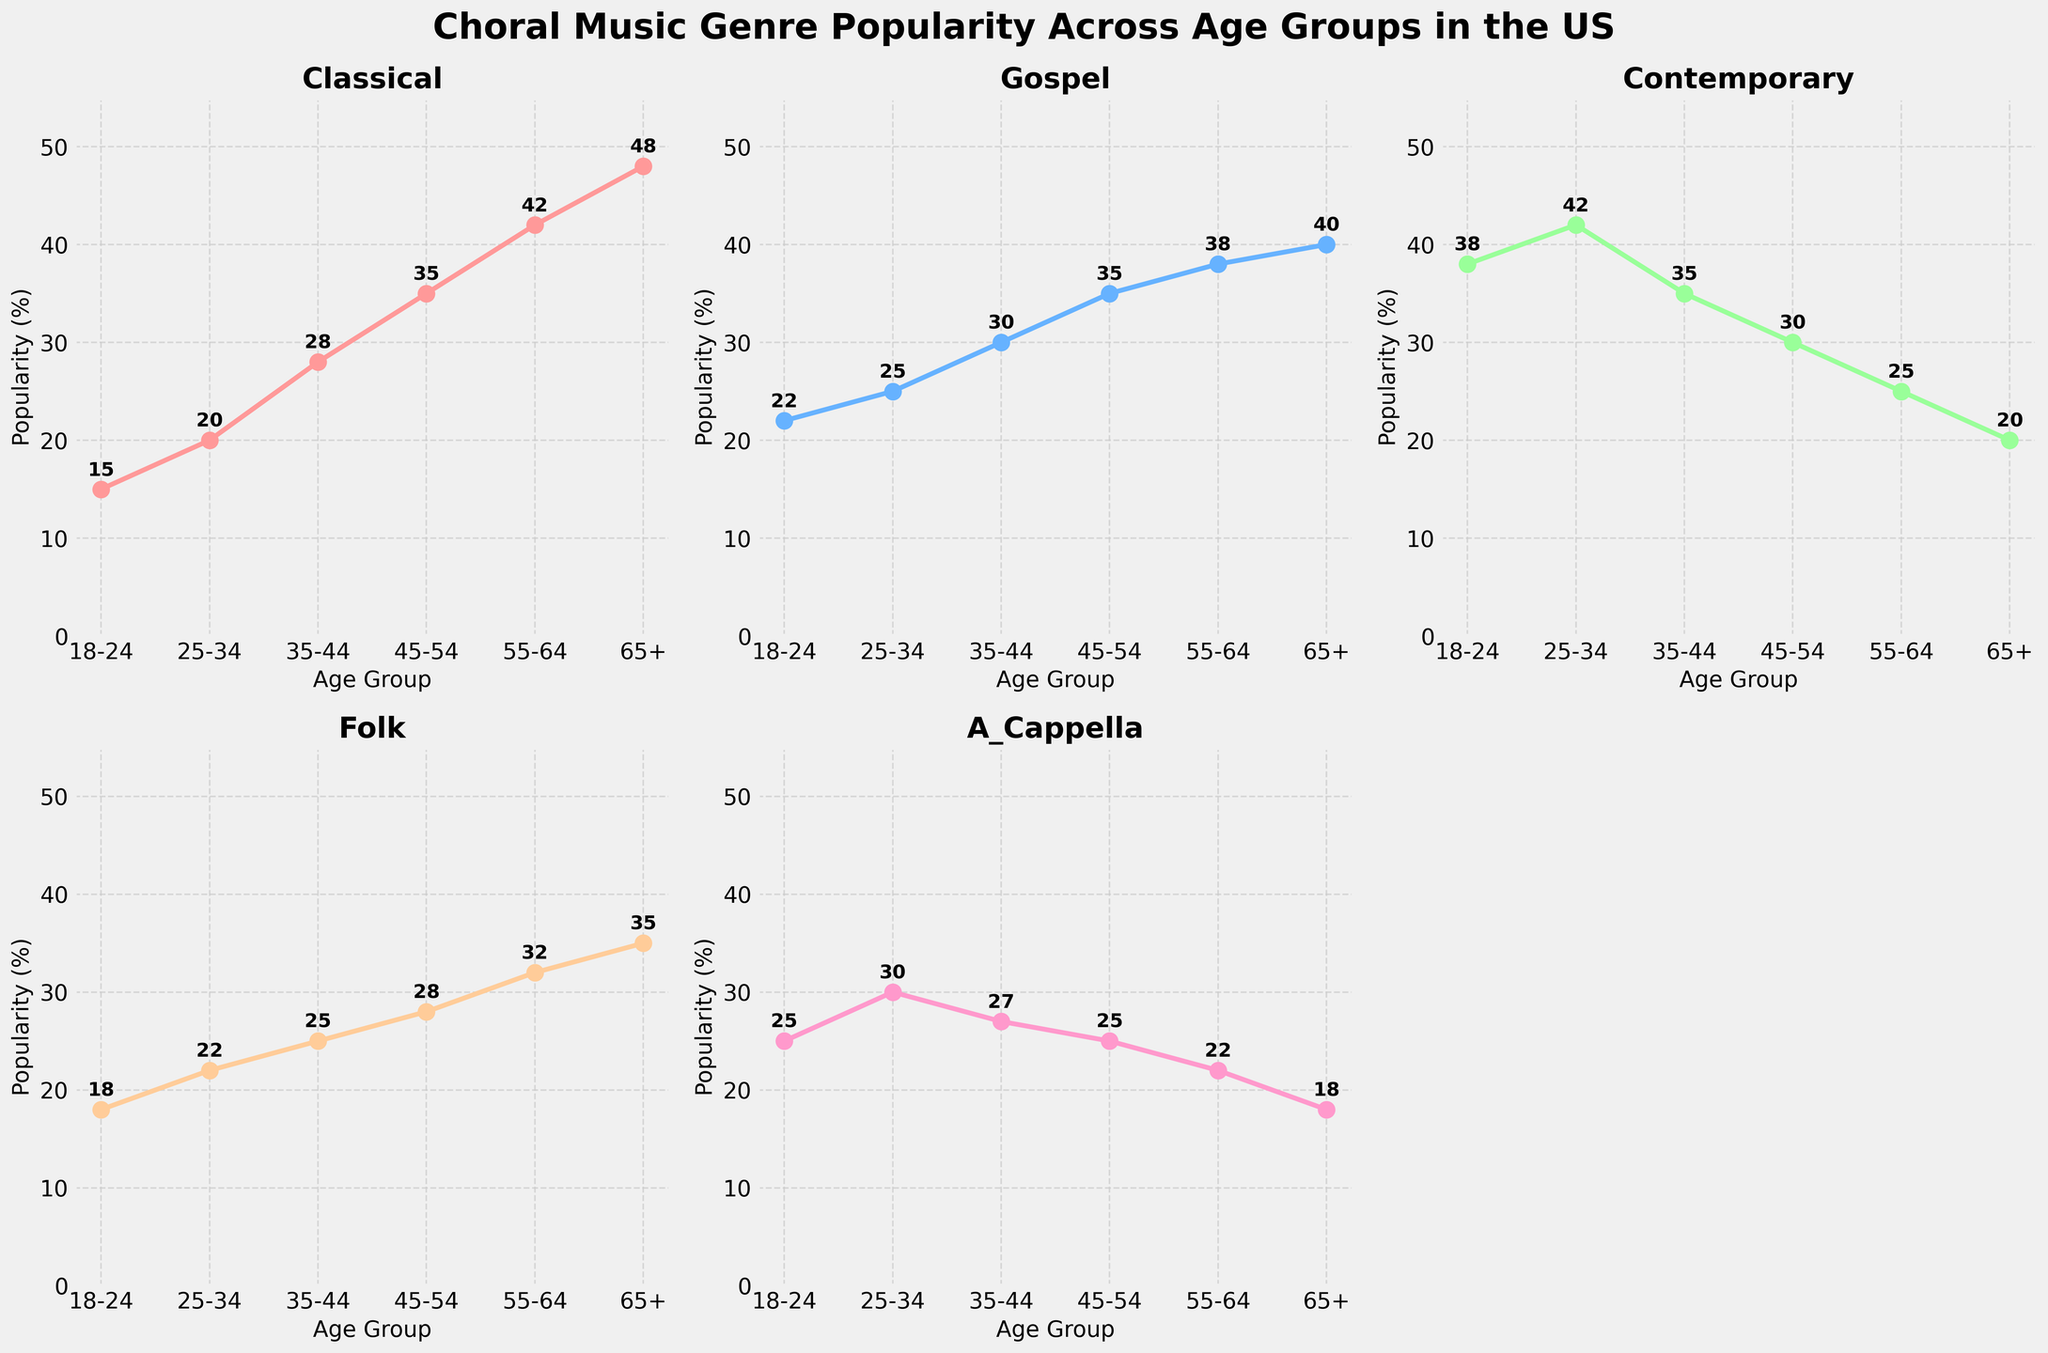What age group shows the highest popularity percentage for Classical music? By observing the plot for the Classical genre, the line peaks at the 65+ age group. This can be confirmed by looking at the percentage values beside each marker on the plot.
Answer: 65+ Compare the popularity percentages of Contemporary music for the 25-34 and 55-64 age groups. Which age group has higher popularity? From the Contemporary music plot, the 25-34 age group shows a higher percentage value compared to the 55-64 age group. The markers and the values next to them indicate 42% for 25-34 and 25% for 55-64.
Answer: 25-34 What is the average popularity percentage for Gospel music across all age groups? To find the average, sum the percentages for Gospel music across all age groups and divide by the number of age groups. The values are 22, 25, 30, 35, 38, and 40. Summing these gives 190, and dividing by 6 gives an average of 31.67.
Answer: 31.67 How does the popularity of Folk music differ between the 18-24 and 65+ age groups? By looking at the Folk music plot, we can find the values for the 18-24 and 65+ age groups. The values are 18% for 18-24 and 35% for 65+. The difference is calculated as 35 - 18, which equals 17.
Answer: 17 Compare the trend of A Cappella music's popularity across age groups 18-24, 25-34, and 35-44. Which age group has the highest popularity? In the plot for A Cappella, the popularity values are plotted as 25% for 18-24, 30% for 25-34, and 27% for 35-44. Therefore, the 25-34 age group has the highest popularity rate among the three.
Answer: 25-34 Which genre shows a consistent increase in popularity as the age group increases from 18-24 to 65+? By comparing all the plots, we can see that the Classical genre shows a consistent increase in popularity as we move from 18-24 to 65+. The markers indicate an upward trend throughout the age groups.
Answer: Classical What is the difference in percentages between the least and most popular genres for the age group 45-54? The specific values for the 45-54 age group are observed across the plots: Classical is 35%, Gospel is 35%, Contemporary is 30%, Folk is 28%, and A Cappella is 25%. The difference between the most (35% for Gospel/Classical) and the least (25% for A Cappella) is 10.
Answer: 10 What color represents the trend for Gospel music in the figure? Based on the color legend given in the code, Gospel music is plotted using the color that corresponds to its position in the genres list, which is '#66B2FF'. In visual terms, it is a shade of blue.
Answer: Blue Combining Classical and Folk music, what is the total percentage of popularity for the 55-64 age group? First, look at the individual percentages for Classical and Folk music in the 55-64 age group. Classical is at 42%, and Folk is at 32%. Summing these two gives 74.
Answer: 74 Which age group has the closest popularity percentages for Gospel and Contemporary music? By observing the Gospel and Contemporary plots side-by-side, the 45-54 age group displays similar values: 35% for Gospel and 30% for Contemporary. This is the smallest difference among other age groups.
Answer: 45-54 